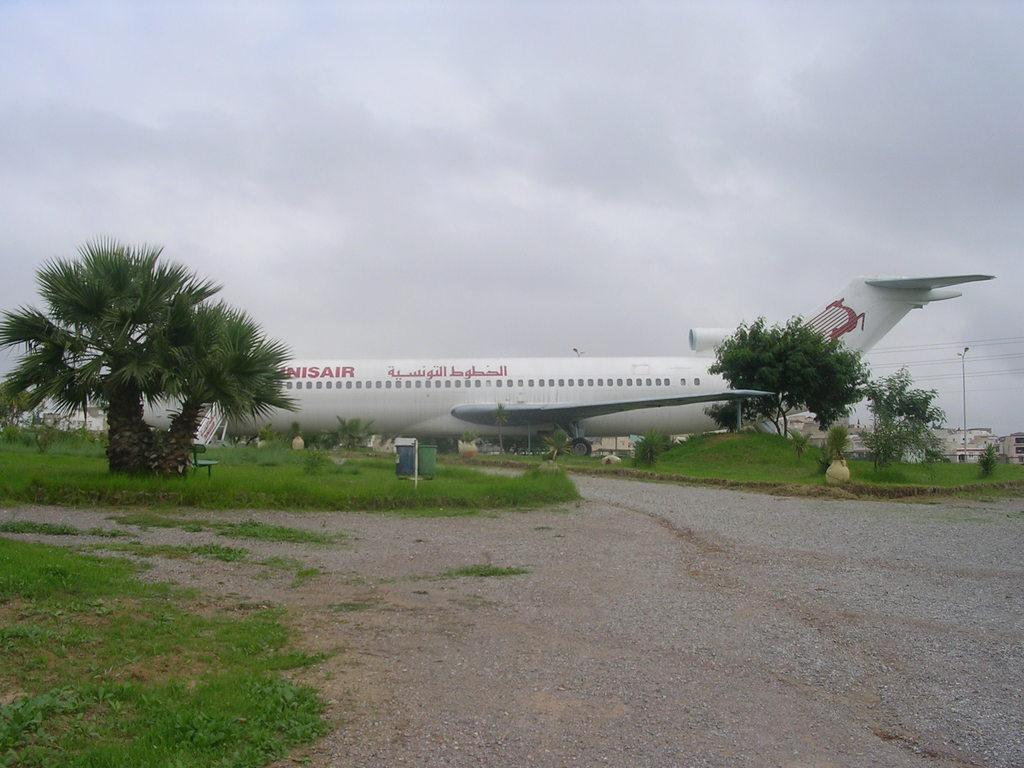Please provide a concise description of this image. In this image I can see an aeroplane. Also there are trees, buildings,pole,cables,grass ,bench and some other objects on the ground. And in the background there is sky. 